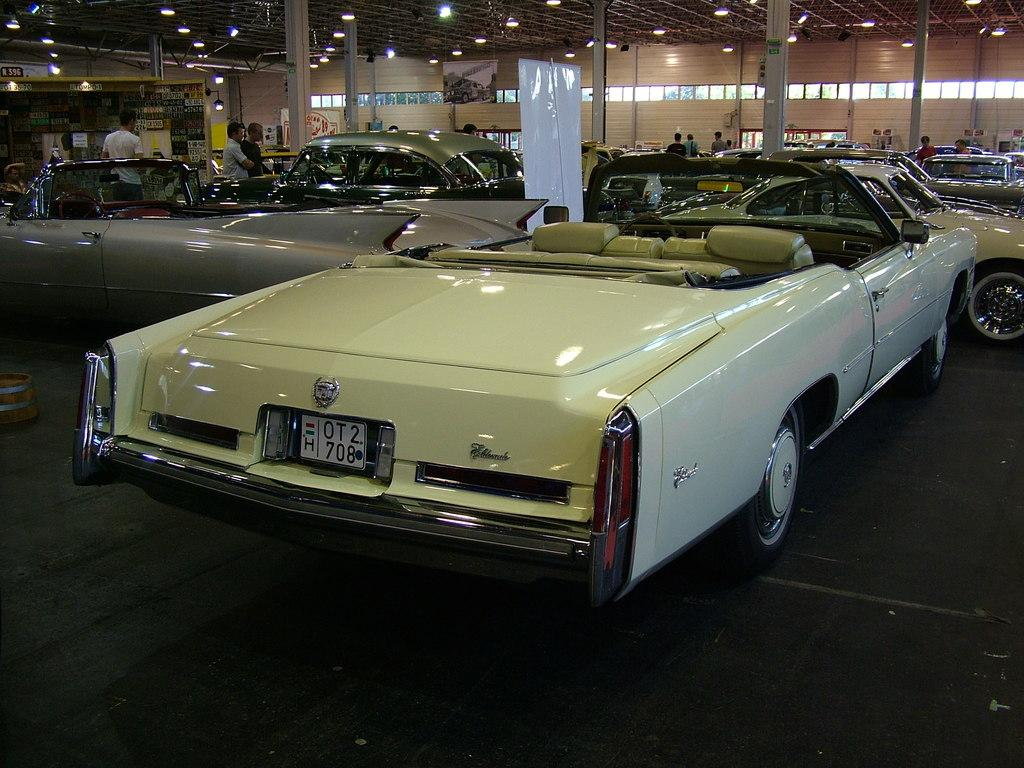What type of structure is shown in the image? The image is an inside view of a shed. What can be seen outside the shed? There are cars visible on the road outside the shed. Can you describe the people in the background? There are people in the background, but their specific actions or activities are not visible in the image. What other objects can be seen in the background? There are boards, poles, and lights visible in the background. What type of produce is being stitched together by the crowd in the image? There is no produce or crowd present in the image; it is an inside view of a shed with people and objects in the background. 